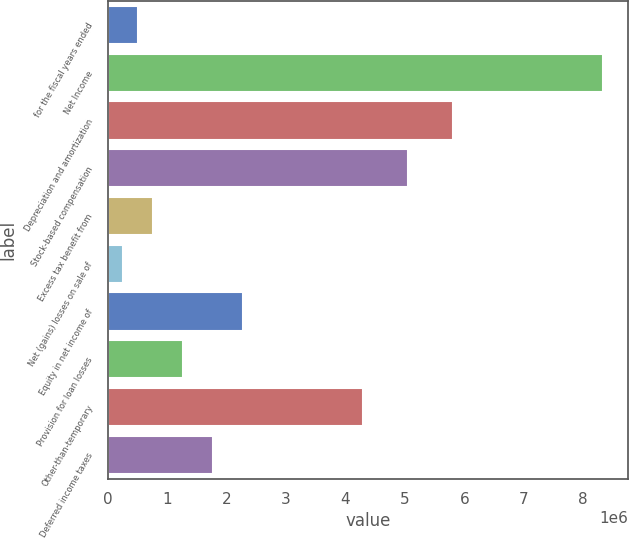Convert chart. <chart><loc_0><loc_0><loc_500><loc_500><bar_chart><fcel>for the fiscal years ended<fcel>Net Income<fcel>Depreciation and amortization<fcel>Stock-based compensation<fcel>Excess tax benefit from<fcel>Net (gains) losses on sale of<fcel>Equity in net income of<fcel>Provision for loan losses<fcel>Other-than-temporary<fcel>Deferred income taxes<nl><fcel>505511<fcel>8.34092e+06<fcel>5.81337e+06<fcel>5.0551e+06<fcel>758266<fcel>252756<fcel>2.2748e+06<fcel>1.26378e+06<fcel>4.29684e+06<fcel>1.76929e+06<nl></chart> 